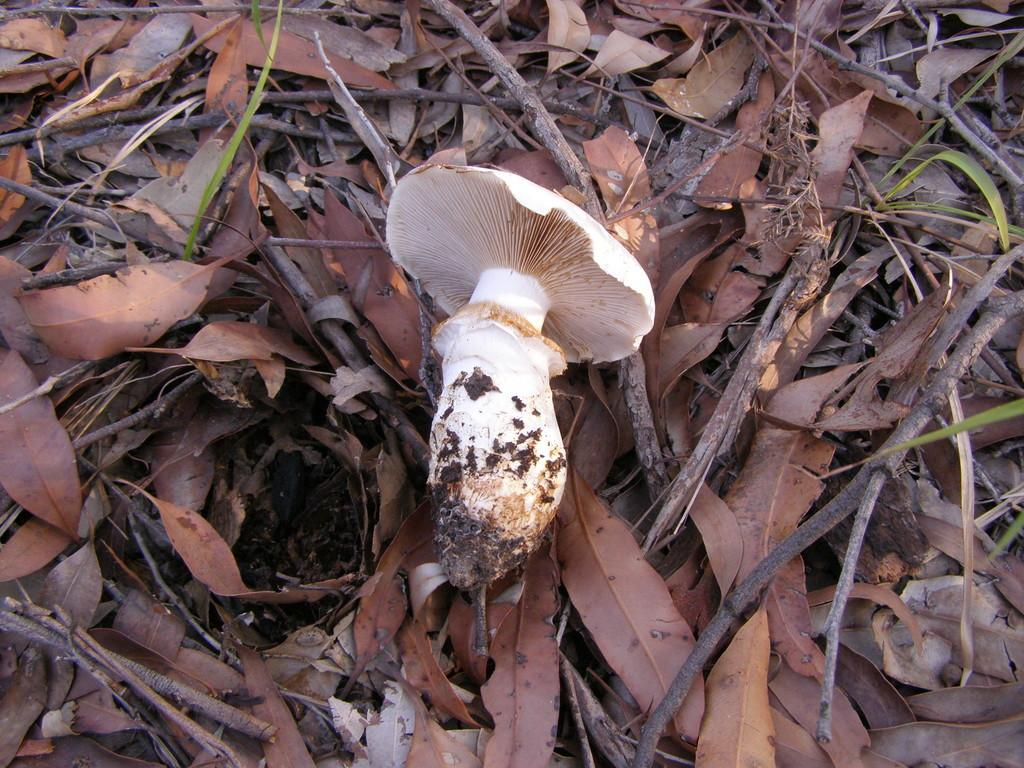What type of plant is featured in the image? There is a mushroom in the image. What type of vegetation can be seen in the image besides the mushroom? Dry leaves and green leaves are visible in the image. What other natural elements are present in the image? Twigs are in the image. How many cubs are playing with the mushroom in the image? There are no cubs present in the image; it features a mushroom, dry leaves, green leaves, and twigs. What type of earth is visible in the image? The image does not show any specific type of earth; it features a mushroom, dry leaves, green leaves, and twigs. 